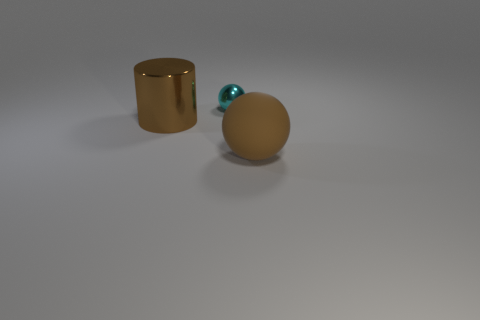Add 3 blue rubber cylinders. How many objects exist? 6 Subtract all spheres. How many objects are left? 1 Add 1 small cyan spheres. How many small cyan spheres are left? 2 Add 2 purple shiny spheres. How many purple shiny spheres exist? 2 Subtract 0 blue blocks. How many objects are left? 3 Subtract all large brown shiny things. Subtract all tiny balls. How many objects are left? 1 